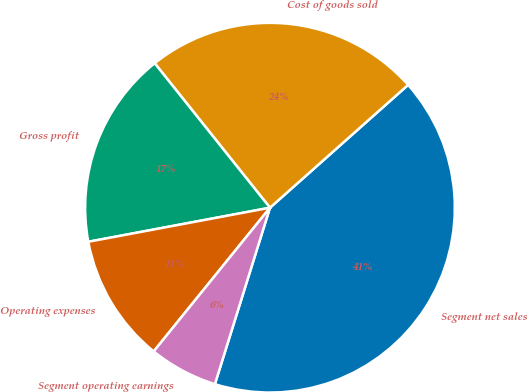<chart> <loc_0><loc_0><loc_500><loc_500><pie_chart><fcel>Segment net sales<fcel>Cost of goods sold<fcel>Gross profit<fcel>Operating expenses<fcel>Segment operating earnings<nl><fcel>41.38%<fcel>24.15%<fcel>17.23%<fcel>11.22%<fcel>6.01%<nl></chart> 